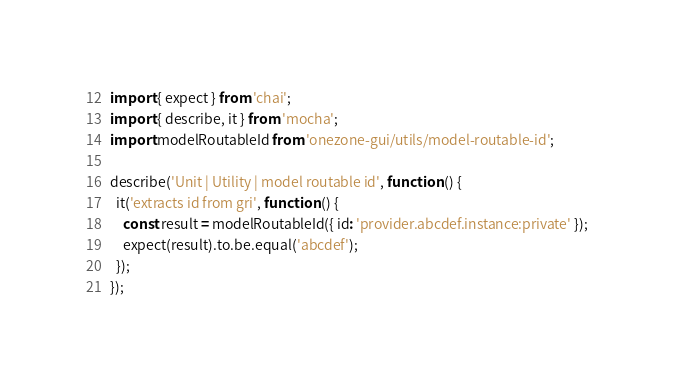<code> <loc_0><loc_0><loc_500><loc_500><_JavaScript_>import { expect } from 'chai';
import { describe, it } from 'mocha';
import modelRoutableId from 'onezone-gui/utils/model-routable-id';

describe('Unit | Utility | model routable id', function () {
  it('extracts id from gri', function () {
    const result = modelRoutableId({ id: 'provider.abcdef.instance:private' });
    expect(result).to.be.equal('abcdef');
  });
});
</code> 